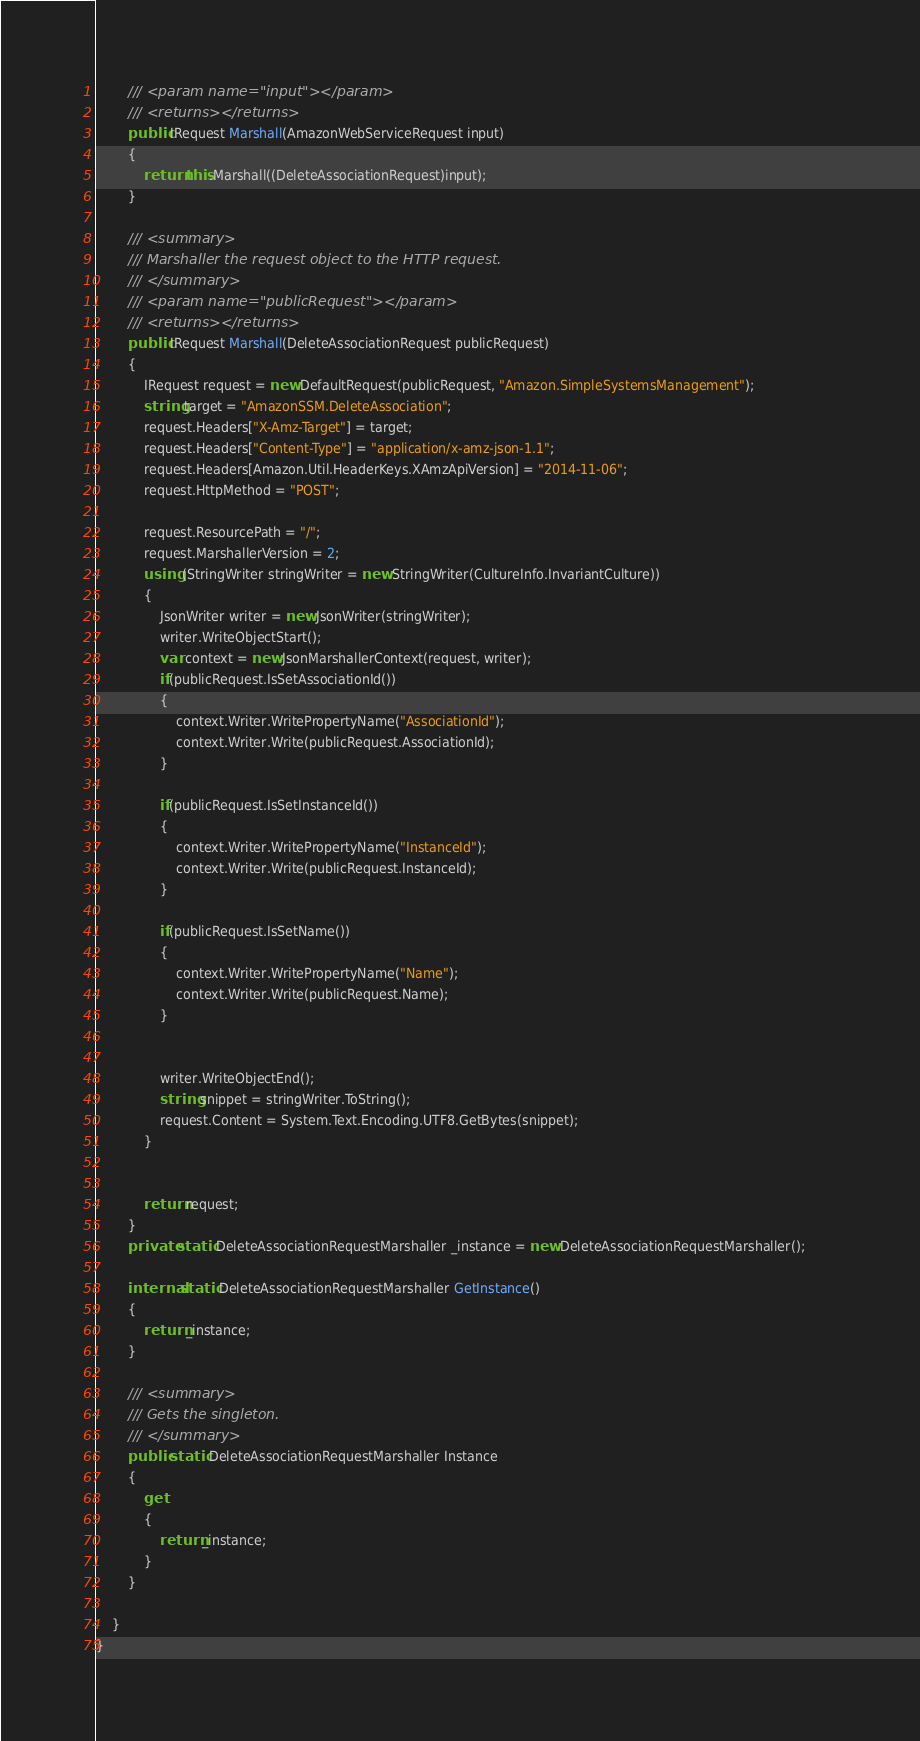Convert code to text. <code><loc_0><loc_0><loc_500><loc_500><_C#_>        /// <param name="input"></param>
        /// <returns></returns>
        public IRequest Marshall(AmazonWebServiceRequest input)
        {
            return this.Marshall((DeleteAssociationRequest)input);
        }

        /// <summary>
        /// Marshaller the request object to the HTTP request.
        /// </summary>  
        /// <param name="publicRequest"></param>
        /// <returns></returns>
        public IRequest Marshall(DeleteAssociationRequest publicRequest)
        {
            IRequest request = new DefaultRequest(publicRequest, "Amazon.SimpleSystemsManagement");
            string target = "AmazonSSM.DeleteAssociation";
            request.Headers["X-Amz-Target"] = target;
            request.Headers["Content-Type"] = "application/x-amz-json-1.1";
            request.Headers[Amazon.Util.HeaderKeys.XAmzApiVersion] = "2014-11-06";            
            request.HttpMethod = "POST";

            request.ResourcePath = "/";
            request.MarshallerVersion = 2;
            using (StringWriter stringWriter = new StringWriter(CultureInfo.InvariantCulture))
            {
                JsonWriter writer = new JsonWriter(stringWriter);
                writer.WriteObjectStart();
                var context = new JsonMarshallerContext(request, writer);
                if(publicRequest.IsSetAssociationId())
                {
                    context.Writer.WritePropertyName("AssociationId");
                    context.Writer.Write(publicRequest.AssociationId);
                }

                if(publicRequest.IsSetInstanceId())
                {
                    context.Writer.WritePropertyName("InstanceId");
                    context.Writer.Write(publicRequest.InstanceId);
                }

                if(publicRequest.IsSetName())
                {
                    context.Writer.WritePropertyName("Name");
                    context.Writer.Write(publicRequest.Name);
                }

        
                writer.WriteObjectEnd();
                string snippet = stringWriter.ToString();
                request.Content = System.Text.Encoding.UTF8.GetBytes(snippet);
            }


            return request;
        }
        private static DeleteAssociationRequestMarshaller _instance = new DeleteAssociationRequestMarshaller();        

        internal static DeleteAssociationRequestMarshaller GetInstance()
        {
            return _instance;
        }

        /// <summary>
        /// Gets the singleton.
        /// </summary>  
        public static DeleteAssociationRequestMarshaller Instance
        {
            get
            {
                return _instance;
            }
        }

    }
}</code> 